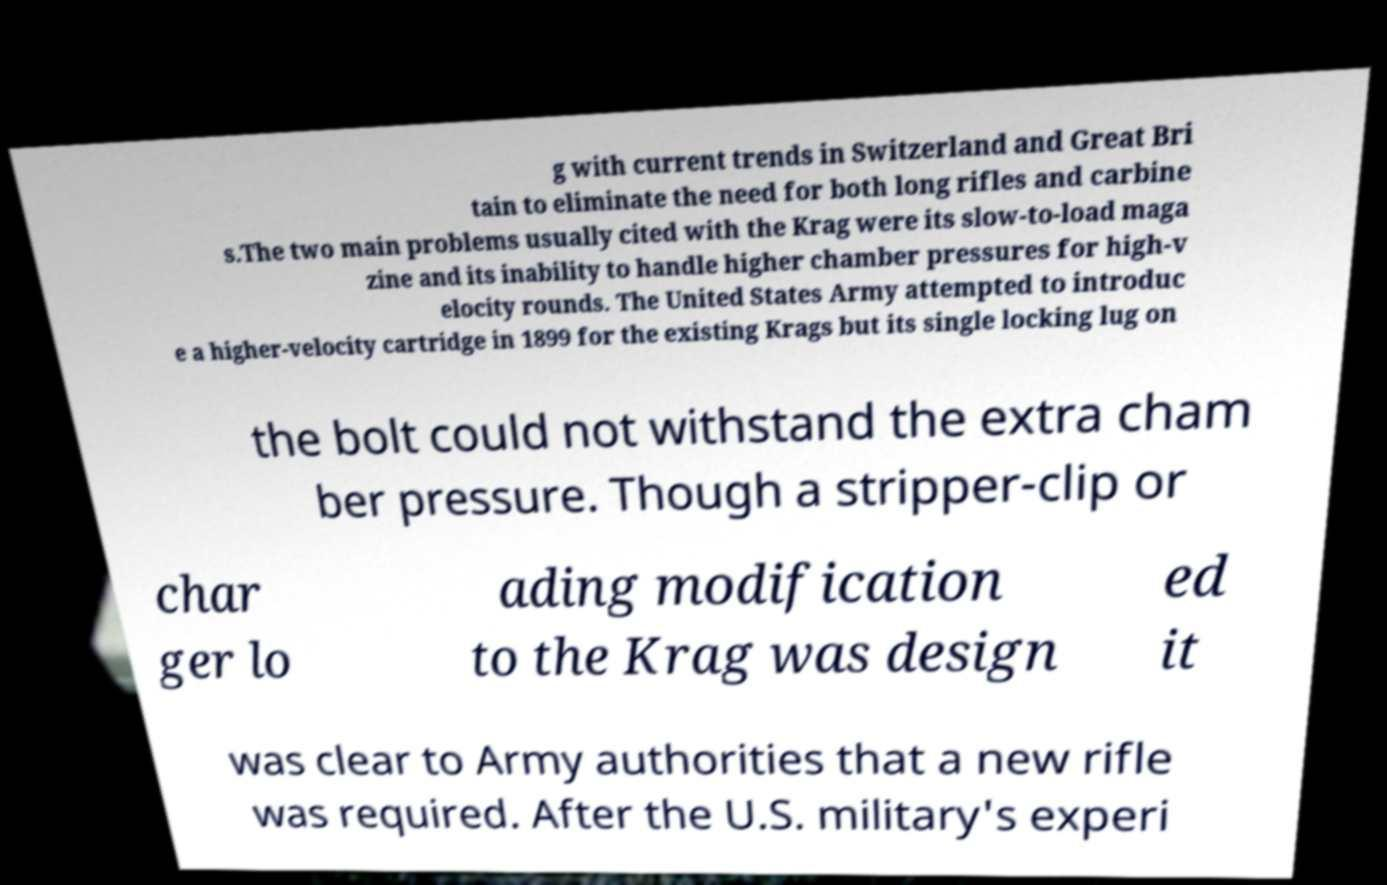Could you extract and type out the text from this image? g with current trends in Switzerland and Great Bri tain to eliminate the need for both long rifles and carbine s.The two main problems usually cited with the Krag were its slow-to-load maga zine and its inability to handle higher chamber pressures for high-v elocity rounds. The United States Army attempted to introduc e a higher-velocity cartridge in 1899 for the existing Krags but its single locking lug on the bolt could not withstand the extra cham ber pressure. Though a stripper-clip or char ger lo ading modification to the Krag was design ed it was clear to Army authorities that a new rifle was required. After the U.S. military's experi 